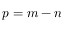Convert formula to latex. <formula><loc_0><loc_0><loc_500><loc_500>p = m - n</formula> 